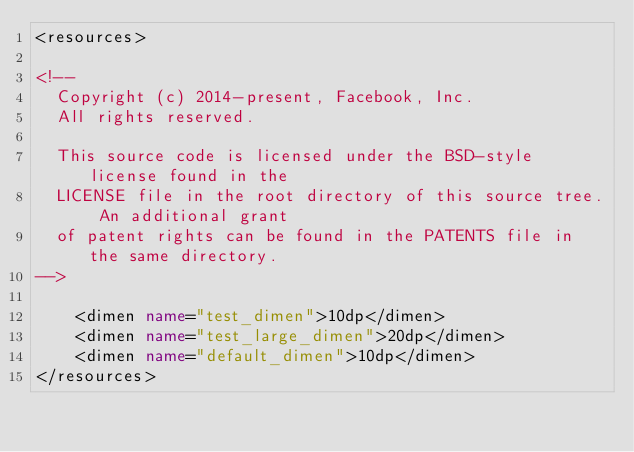Convert code to text. <code><loc_0><loc_0><loc_500><loc_500><_XML_><resources>

<!--
  Copyright (c) 2014-present, Facebook, Inc.
  All rights reserved.

  This source code is licensed under the BSD-style license found in the
  LICENSE file in the root directory of this source tree. An additional grant
  of patent rights can be found in the PATENTS file in the same directory.
-->

    <dimen name="test_dimen">10dp</dimen>
    <dimen name="test_large_dimen">20dp</dimen>
    <dimen name="default_dimen">10dp</dimen>
</resources>
</code> 